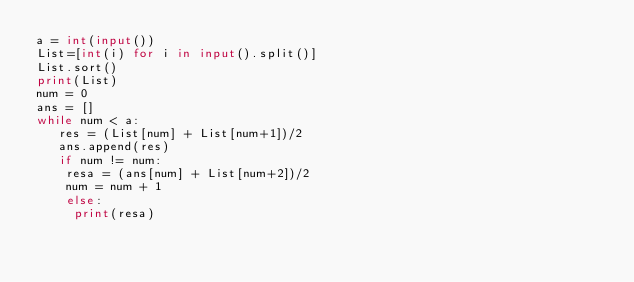Convert code to text. <code><loc_0><loc_0><loc_500><loc_500><_Python_>a = int(input())
List=[int(i) for i in input().split()]
List.sort()
print(List)
num = 0
ans = []
while num < a:
   res = (List[num] + List[num+1])/2
   ans.append(res)
   if num != num:
    resa = (ans[num] + List[num+2])/2
    num = num + 1
    else:
     print(resa)
</code> 